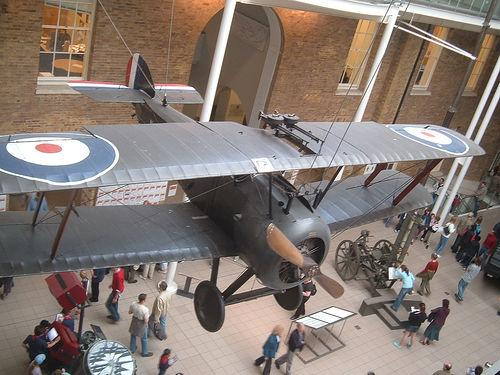What does this building house? Please explain your reasoning. museum. This is a museum. you can see the plane is hung up and on display for people to look at. 